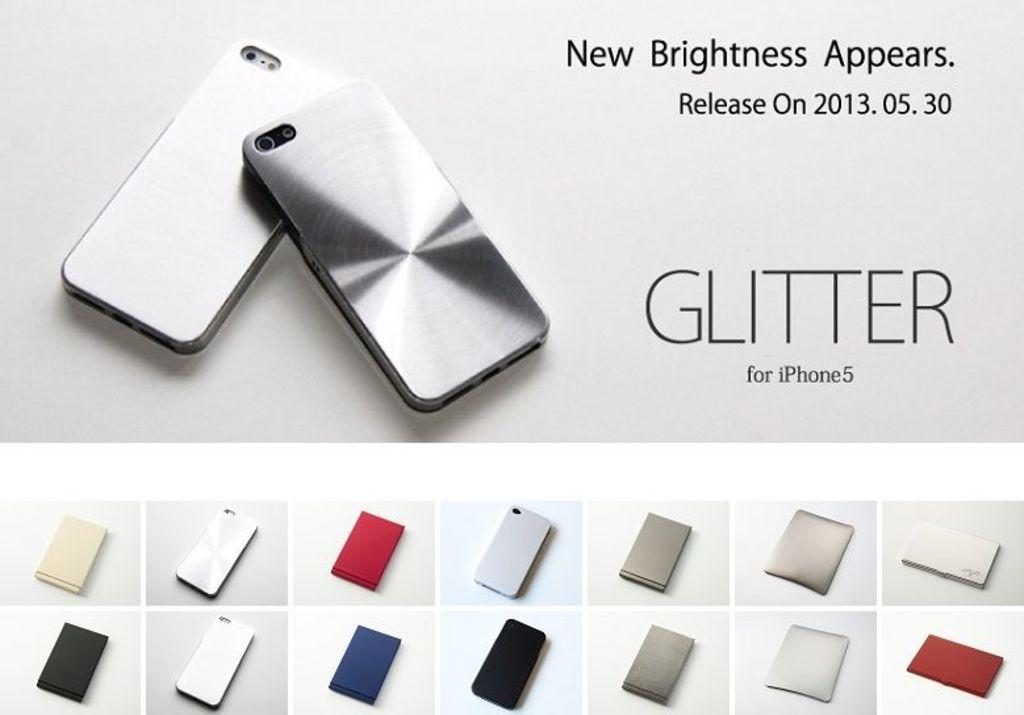<image>
Present a compact description of the photo's key features. An advertisement for a Glitter case to be used on an iPhone 5 